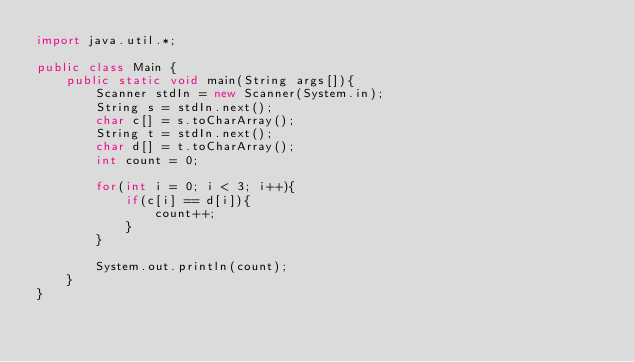<code> <loc_0><loc_0><loc_500><loc_500><_Java_>import java.util.*;

public class Main {
    public static void main(String args[]){
        Scanner stdIn = new Scanner(System.in);
        String s = stdIn.next();
        char c[] = s.toCharArray();
        String t = stdIn.next();
        char d[] = t.toCharArray();
        int count = 0;
        
        for(int i = 0; i < 3; i++){
            if(c[i] == d[i]){
                count++;
            }
        }
        
        System.out.println(count);
    }
}
</code> 